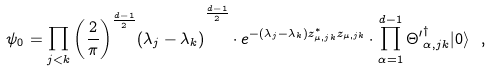<formula> <loc_0><loc_0><loc_500><loc_500>\psi _ { 0 } = \prod _ { j < k } { { \left ( \frac { 2 } { \pi } \right ) } ^ { \frac { d - 1 } { 2 } } ( \lambda _ { j } - \lambda _ { k } ) } ^ { \frac { d - 1 } { 2 } } \cdot e ^ { - ( \lambda _ { j } - \lambda _ { k } ) z ^ { \ast } _ { \mu , j k } z _ { \mu , j k } } \cdot \prod _ { \alpha = 1 } ^ { d - 1 } { \Theta ^ { \prime } } ^ { \dagger } _ { \alpha , j k } | 0 \rangle \ ,</formula> 